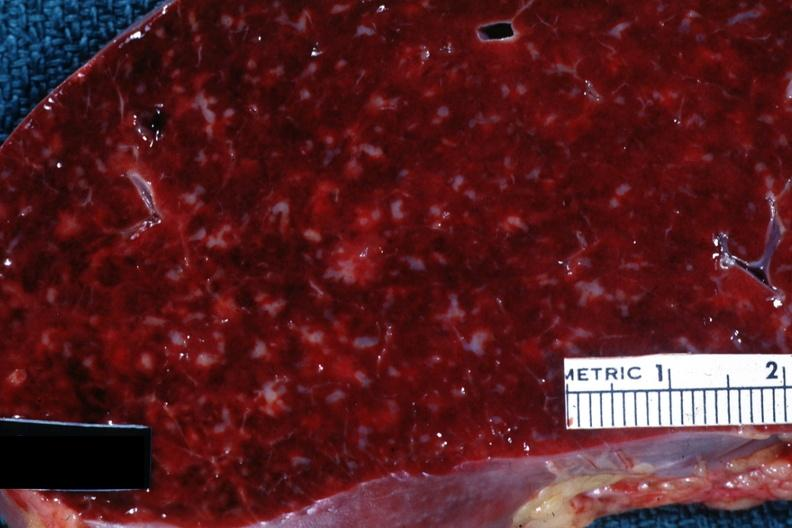does this image show close-up with obvious small infiltrates of something?
Answer the question using a single word or phrase. Yes 